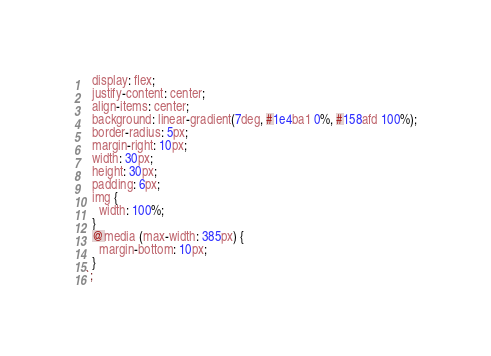Convert code to text. <code><loc_0><loc_0><loc_500><loc_500><_JavaScript_>  display: flex;
  justify-content: center;
  align-items: center;
  background: linear-gradient(7deg, #1e4ba1 0%, #158afd 100%);
  border-radius: 5px;
  margin-right: 10px;
  width: 30px;
  height: 30px;
  padding: 6px;
  img {
    width: 100%;
  }
  @media (max-width: 385px) {
    margin-bottom: 10px;
  }
`;
</code> 